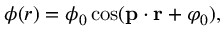Convert formula to latex. <formula><loc_0><loc_0><loc_500><loc_500>\phi ( r ) = \phi _ { 0 } \cos ( { p } \cdot { r } + \varphi _ { 0 } ) ,</formula> 